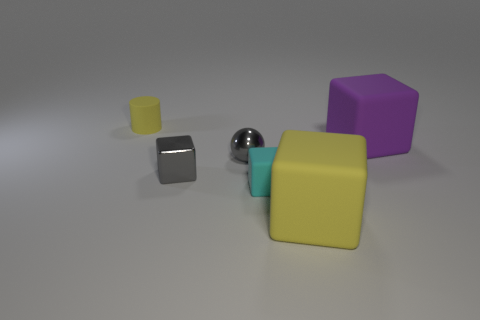What textures are present on the objects, and what do they suggest about the material? The objects have different textures. The cubes have a matte finish, suggesting a non-reflective material like plastic, while the sphere has a reflective surface, indicating a smoother and possibly metallic material. Could you use these items in a practical way, or do they serve another purpose? While the objects could theoretically be used as decorative pieces or in educational settings to teach about shapes and light, their primary purpose here seems to be for a visual display, possibly for artistic or illustrative use. 